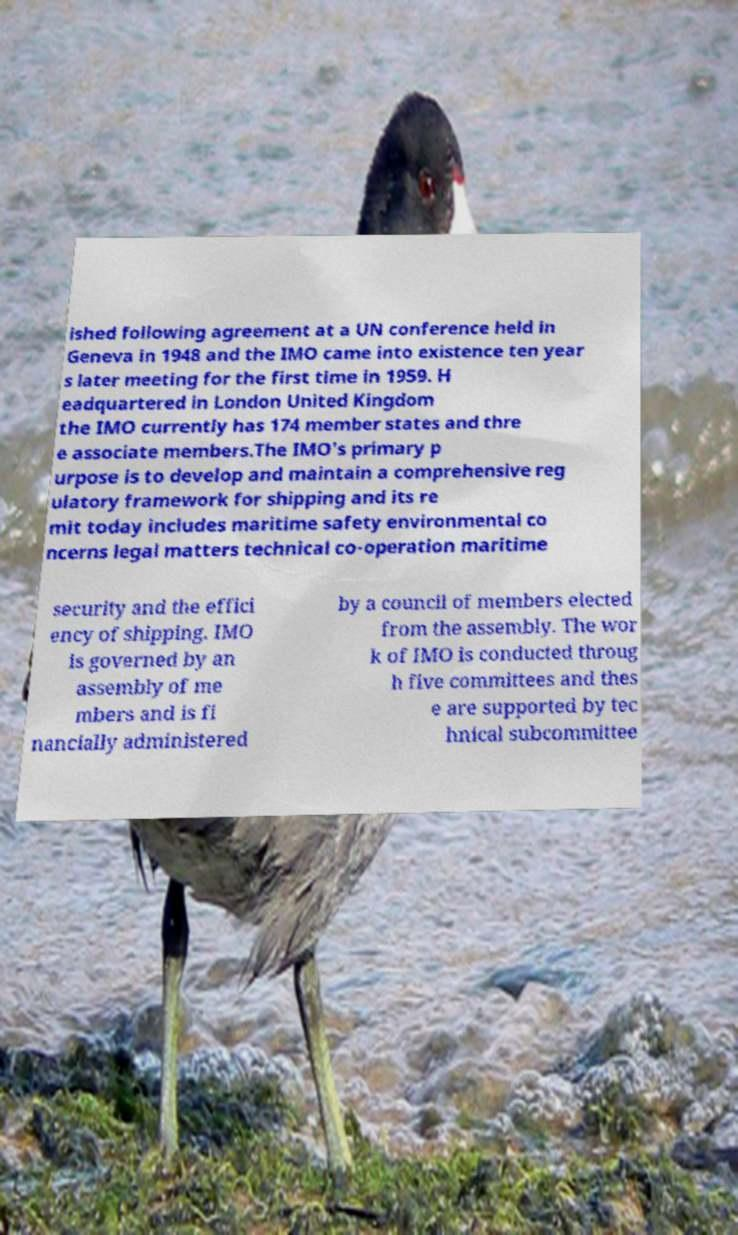Please identify and transcribe the text found in this image. ished following agreement at a UN conference held in Geneva in 1948 and the IMO came into existence ten year s later meeting for the first time in 1959. H eadquartered in London United Kingdom the IMO currently has 174 member states and thre e associate members.The IMO's primary p urpose is to develop and maintain a comprehensive reg ulatory framework for shipping and its re mit today includes maritime safety environmental co ncerns legal matters technical co-operation maritime security and the effici ency of shipping. IMO is governed by an assembly of me mbers and is fi nancially administered by a council of members elected from the assembly. The wor k of IMO is conducted throug h five committees and thes e are supported by tec hnical subcommittee 